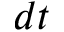Convert formula to latex. <formula><loc_0><loc_0><loc_500><loc_500>d t</formula> 